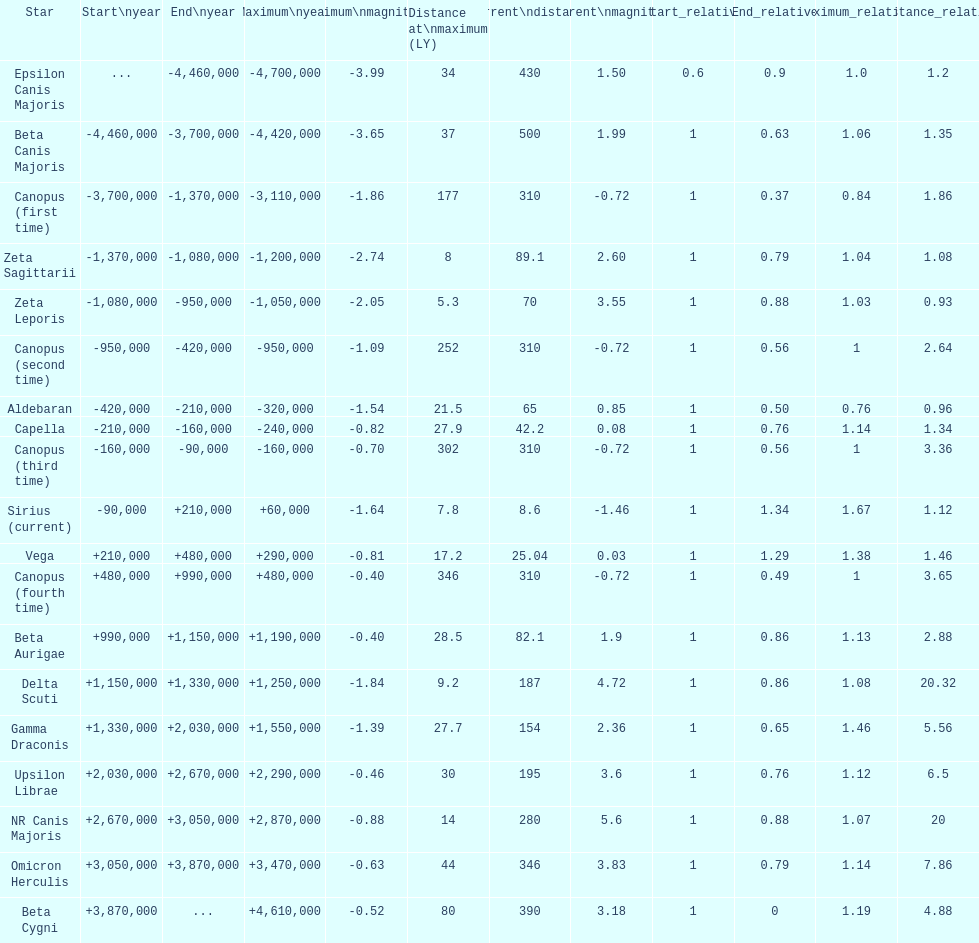What is the number of stars that have a maximum magnitude less than zero? 5. Could you help me parse every detail presented in this table? {'header': ['Star', 'Start\\nyear', 'End\\nyear', 'Maximum\\nyear', 'Maximum\\nmagnitude', 'Distance at\\nmaximum (LY)', 'Current\\ndistance', 'Current\\nmagnitude', 'Start_relative', 'End_relative', 'Maximum_relative', 'Distance_relative'], 'rows': [['Epsilon Canis Majoris', '...', '-4,460,000', '-4,700,000', '-3.99', '34', '430', '1.50', '0.6', '0.9', '1.0', '1.2'], ['Beta Canis Majoris', '-4,460,000', '-3,700,000', '-4,420,000', '-3.65', '37', '500', '1.99', '1', '0.63', '1.06', '1.35'], ['Canopus (first time)', '-3,700,000', '-1,370,000', '-3,110,000', '-1.86', '177', '310', '-0.72', '1', '0.37', '0.84', '1.86'], ['Zeta Sagittarii', '-1,370,000', '-1,080,000', '-1,200,000', '-2.74', '8', '89.1', '2.60', '1', '0.79', '1.04', '1.08'], ['Zeta Leporis', '-1,080,000', '-950,000', '-1,050,000', '-2.05', '5.3', '70', '3.55', '1', '0.88', '1.03', '0.93'], ['Canopus (second time)', '-950,000', '-420,000', '-950,000', '-1.09', '252', '310', '-0.72', '1', '0.56', '1', '2.64'], ['Aldebaran', '-420,000', '-210,000', '-320,000', '-1.54', '21.5', '65', '0.85', '1', '0.50', '0.76', '0.96'], ['Capella', '-210,000', '-160,000', '-240,000', '-0.82', '27.9', '42.2', '0.08', '1', '0.76', '1.14', '1.34'], ['Canopus (third time)', '-160,000', '-90,000', '-160,000', '-0.70', '302', '310', '-0.72', '1', '0.56', '1', '3.36'], ['Sirius (current)', '-90,000', '+210,000', '+60,000', '-1.64', '7.8', '8.6', '-1.46', '1', '1.34', '1.67', '1.12'], ['Vega', '+210,000', '+480,000', '+290,000', '-0.81', '17.2', '25.04', '0.03', '1', '1.29', '1.38', '1.46'], ['Canopus (fourth time)', '+480,000', '+990,000', '+480,000', '-0.40', '346', '310', '-0.72', '1', '0.49', '1', '3.65'], ['Beta Aurigae', '+990,000', '+1,150,000', '+1,190,000', '-0.40', '28.5', '82.1', '1.9', '1', '0.86', '1.13', '2.88'], ['Delta Scuti', '+1,150,000', '+1,330,000', '+1,250,000', '-1.84', '9.2', '187', '4.72', '1', '0.86', '1.08', '20.32'], ['Gamma Draconis', '+1,330,000', '+2,030,000', '+1,550,000', '-1.39', '27.7', '154', '2.36', '1', '0.65', '1.46', '5.56'], ['Upsilon Librae', '+2,030,000', '+2,670,000', '+2,290,000', '-0.46', '30', '195', '3.6', '1', '0.76', '1.12', '6.5'], ['NR Canis Majoris', '+2,670,000', '+3,050,000', '+2,870,000', '-0.88', '14', '280', '5.6', '1', '0.88', '1.07', '20'], ['Omicron Herculis', '+3,050,000', '+3,870,000', '+3,470,000', '-0.63', '44', '346', '3.83', '1', '0.79', '1.14', '7.86'], ['Beta Cygni', '+3,870,000', '...', '+4,610,000', '-0.52', '80', '390', '3.18', '1', '0', '1.19', '4.88']]} 